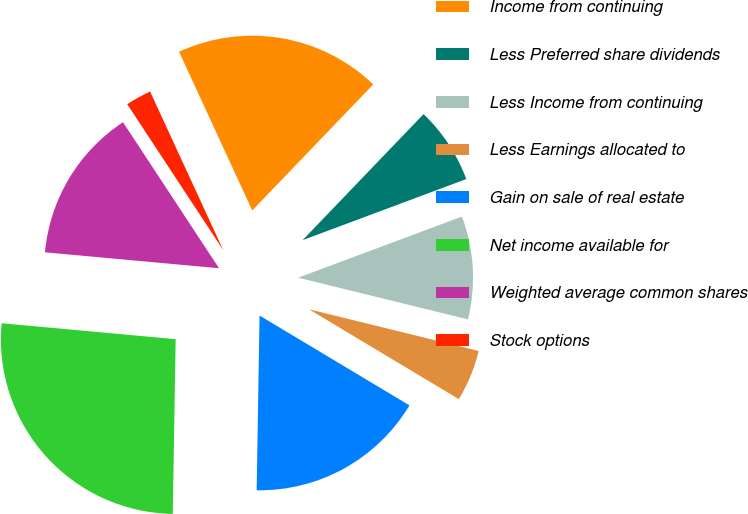<chart> <loc_0><loc_0><loc_500><loc_500><pie_chart><fcel>Income from continuing<fcel>Less Preferred share dividends<fcel>Less Income from continuing<fcel>Less Earnings allocated to<fcel>Gain on sale of real estate<fcel>Net income available for<fcel>Weighted average common shares<fcel>Stock options<nl><fcel>19.05%<fcel>7.14%<fcel>9.52%<fcel>4.76%<fcel>16.67%<fcel>26.19%<fcel>14.29%<fcel>2.38%<nl></chart> 